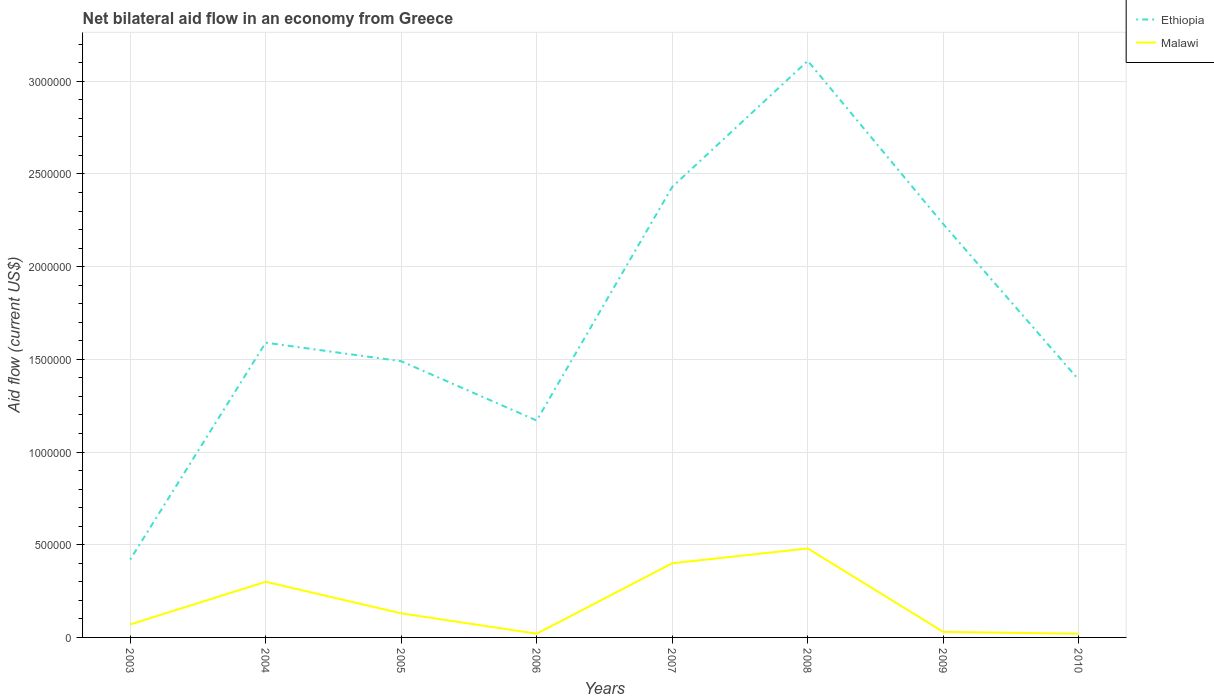Does the line corresponding to Malawi intersect with the line corresponding to Ethiopia?
Your answer should be very brief. No. Is the number of lines equal to the number of legend labels?
Your answer should be compact. Yes. Across all years, what is the maximum net bilateral aid flow in Ethiopia?
Offer a terse response. 4.20e+05. What is the total net bilateral aid flow in Ethiopia in the graph?
Offer a terse response. -2.01e+06. What is the difference between the highest and the second highest net bilateral aid flow in Ethiopia?
Your answer should be very brief. 2.69e+06. How many years are there in the graph?
Your response must be concise. 8. What is the difference between two consecutive major ticks on the Y-axis?
Your response must be concise. 5.00e+05. Are the values on the major ticks of Y-axis written in scientific E-notation?
Keep it short and to the point. No. Does the graph contain any zero values?
Offer a terse response. No. How many legend labels are there?
Ensure brevity in your answer.  2. How are the legend labels stacked?
Make the answer very short. Vertical. What is the title of the graph?
Offer a terse response. Net bilateral aid flow in an economy from Greece. Does "Channel Islands" appear as one of the legend labels in the graph?
Give a very brief answer. No. What is the Aid flow (current US$) of Ethiopia in 2004?
Your response must be concise. 1.59e+06. What is the Aid flow (current US$) of Malawi in 2004?
Offer a terse response. 3.00e+05. What is the Aid flow (current US$) of Ethiopia in 2005?
Provide a succinct answer. 1.49e+06. What is the Aid flow (current US$) of Malawi in 2005?
Make the answer very short. 1.30e+05. What is the Aid flow (current US$) of Ethiopia in 2006?
Your answer should be compact. 1.17e+06. What is the Aid flow (current US$) in Malawi in 2006?
Offer a terse response. 2.00e+04. What is the Aid flow (current US$) of Ethiopia in 2007?
Keep it short and to the point. 2.43e+06. What is the Aid flow (current US$) in Ethiopia in 2008?
Offer a very short reply. 3.11e+06. What is the Aid flow (current US$) in Malawi in 2008?
Offer a terse response. 4.80e+05. What is the Aid flow (current US$) of Ethiopia in 2009?
Make the answer very short. 2.23e+06. What is the Aid flow (current US$) of Malawi in 2009?
Make the answer very short. 3.00e+04. What is the Aid flow (current US$) in Ethiopia in 2010?
Your answer should be very brief. 1.39e+06. What is the Aid flow (current US$) in Malawi in 2010?
Provide a short and direct response. 2.00e+04. Across all years, what is the maximum Aid flow (current US$) of Ethiopia?
Provide a succinct answer. 3.11e+06. Across all years, what is the maximum Aid flow (current US$) in Malawi?
Make the answer very short. 4.80e+05. Across all years, what is the minimum Aid flow (current US$) of Malawi?
Your response must be concise. 2.00e+04. What is the total Aid flow (current US$) of Ethiopia in the graph?
Keep it short and to the point. 1.38e+07. What is the total Aid flow (current US$) in Malawi in the graph?
Offer a terse response. 1.45e+06. What is the difference between the Aid flow (current US$) in Ethiopia in 2003 and that in 2004?
Offer a very short reply. -1.17e+06. What is the difference between the Aid flow (current US$) in Malawi in 2003 and that in 2004?
Your answer should be compact. -2.30e+05. What is the difference between the Aid flow (current US$) of Ethiopia in 2003 and that in 2005?
Provide a short and direct response. -1.07e+06. What is the difference between the Aid flow (current US$) in Malawi in 2003 and that in 2005?
Offer a very short reply. -6.00e+04. What is the difference between the Aid flow (current US$) in Ethiopia in 2003 and that in 2006?
Make the answer very short. -7.50e+05. What is the difference between the Aid flow (current US$) of Malawi in 2003 and that in 2006?
Provide a succinct answer. 5.00e+04. What is the difference between the Aid flow (current US$) of Ethiopia in 2003 and that in 2007?
Make the answer very short. -2.01e+06. What is the difference between the Aid flow (current US$) of Malawi in 2003 and that in 2007?
Make the answer very short. -3.30e+05. What is the difference between the Aid flow (current US$) in Ethiopia in 2003 and that in 2008?
Your answer should be very brief. -2.69e+06. What is the difference between the Aid flow (current US$) in Malawi in 2003 and that in 2008?
Make the answer very short. -4.10e+05. What is the difference between the Aid flow (current US$) of Ethiopia in 2003 and that in 2009?
Your response must be concise. -1.81e+06. What is the difference between the Aid flow (current US$) in Malawi in 2003 and that in 2009?
Your answer should be compact. 4.00e+04. What is the difference between the Aid flow (current US$) in Ethiopia in 2003 and that in 2010?
Keep it short and to the point. -9.70e+05. What is the difference between the Aid flow (current US$) of Malawi in 2004 and that in 2005?
Your response must be concise. 1.70e+05. What is the difference between the Aid flow (current US$) of Ethiopia in 2004 and that in 2006?
Your response must be concise. 4.20e+05. What is the difference between the Aid flow (current US$) in Ethiopia in 2004 and that in 2007?
Provide a short and direct response. -8.40e+05. What is the difference between the Aid flow (current US$) in Malawi in 2004 and that in 2007?
Your answer should be compact. -1.00e+05. What is the difference between the Aid flow (current US$) in Ethiopia in 2004 and that in 2008?
Make the answer very short. -1.52e+06. What is the difference between the Aid flow (current US$) of Ethiopia in 2004 and that in 2009?
Offer a very short reply. -6.40e+05. What is the difference between the Aid flow (current US$) in Malawi in 2004 and that in 2009?
Give a very brief answer. 2.70e+05. What is the difference between the Aid flow (current US$) of Ethiopia in 2004 and that in 2010?
Your answer should be compact. 2.00e+05. What is the difference between the Aid flow (current US$) in Malawi in 2004 and that in 2010?
Ensure brevity in your answer.  2.80e+05. What is the difference between the Aid flow (current US$) of Ethiopia in 2005 and that in 2007?
Make the answer very short. -9.40e+05. What is the difference between the Aid flow (current US$) of Ethiopia in 2005 and that in 2008?
Give a very brief answer. -1.62e+06. What is the difference between the Aid flow (current US$) of Malawi in 2005 and that in 2008?
Make the answer very short. -3.50e+05. What is the difference between the Aid flow (current US$) of Ethiopia in 2005 and that in 2009?
Ensure brevity in your answer.  -7.40e+05. What is the difference between the Aid flow (current US$) in Malawi in 2005 and that in 2009?
Keep it short and to the point. 1.00e+05. What is the difference between the Aid flow (current US$) in Ethiopia in 2006 and that in 2007?
Provide a short and direct response. -1.26e+06. What is the difference between the Aid flow (current US$) of Malawi in 2006 and that in 2007?
Offer a very short reply. -3.80e+05. What is the difference between the Aid flow (current US$) in Ethiopia in 2006 and that in 2008?
Your response must be concise. -1.94e+06. What is the difference between the Aid flow (current US$) in Malawi in 2006 and that in 2008?
Give a very brief answer. -4.60e+05. What is the difference between the Aid flow (current US$) in Ethiopia in 2006 and that in 2009?
Keep it short and to the point. -1.06e+06. What is the difference between the Aid flow (current US$) in Malawi in 2006 and that in 2009?
Provide a short and direct response. -10000. What is the difference between the Aid flow (current US$) in Malawi in 2006 and that in 2010?
Your answer should be compact. 0. What is the difference between the Aid flow (current US$) in Ethiopia in 2007 and that in 2008?
Your answer should be very brief. -6.80e+05. What is the difference between the Aid flow (current US$) in Malawi in 2007 and that in 2008?
Your answer should be compact. -8.00e+04. What is the difference between the Aid flow (current US$) in Ethiopia in 2007 and that in 2009?
Make the answer very short. 2.00e+05. What is the difference between the Aid flow (current US$) of Ethiopia in 2007 and that in 2010?
Your answer should be compact. 1.04e+06. What is the difference between the Aid flow (current US$) of Malawi in 2007 and that in 2010?
Provide a short and direct response. 3.80e+05. What is the difference between the Aid flow (current US$) in Ethiopia in 2008 and that in 2009?
Your answer should be very brief. 8.80e+05. What is the difference between the Aid flow (current US$) in Ethiopia in 2008 and that in 2010?
Offer a terse response. 1.72e+06. What is the difference between the Aid flow (current US$) of Malawi in 2008 and that in 2010?
Offer a terse response. 4.60e+05. What is the difference between the Aid flow (current US$) in Ethiopia in 2009 and that in 2010?
Give a very brief answer. 8.40e+05. What is the difference between the Aid flow (current US$) in Malawi in 2009 and that in 2010?
Keep it short and to the point. 10000. What is the difference between the Aid flow (current US$) of Ethiopia in 2003 and the Aid flow (current US$) of Malawi in 2004?
Offer a terse response. 1.20e+05. What is the difference between the Aid flow (current US$) in Ethiopia in 2003 and the Aid flow (current US$) in Malawi in 2006?
Keep it short and to the point. 4.00e+05. What is the difference between the Aid flow (current US$) of Ethiopia in 2003 and the Aid flow (current US$) of Malawi in 2007?
Make the answer very short. 2.00e+04. What is the difference between the Aid flow (current US$) in Ethiopia in 2004 and the Aid flow (current US$) in Malawi in 2005?
Offer a very short reply. 1.46e+06. What is the difference between the Aid flow (current US$) in Ethiopia in 2004 and the Aid flow (current US$) in Malawi in 2006?
Provide a succinct answer. 1.57e+06. What is the difference between the Aid flow (current US$) in Ethiopia in 2004 and the Aid flow (current US$) in Malawi in 2007?
Offer a very short reply. 1.19e+06. What is the difference between the Aid flow (current US$) in Ethiopia in 2004 and the Aid flow (current US$) in Malawi in 2008?
Ensure brevity in your answer.  1.11e+06. What is the difference between the Aid flow (current US$) in Ethiopia in 2004 and the Aid flow (current US$) in Malawi in 2009?
Your response must be concise. 1.56e+06. What is the difference between the Aid flow (current US$) in Ethiopia in 2004 and the Aid flow (current US$) in Malawi in 2010?
Keep it short and to the point. 1.57e+06. What is the difference between the Aid flow (current US$) in Ethiopia in 2005 and the Aid flow (current US$) in Malawi in 2006?
Make the answer very short. 1.47e+06. What is the difference between the Aid flow (current US$) in Ethiopia in 2005 and the Aid flow (current US$) in Malawi in 2007?
Provide a short and direct response. 1.09e+06. What is the difference between the Aid flow (current US$) in Ethiopia in 2005 and the Aid flow (current US$) in Malawi in 2008?
Keep it short and to the point. 1.01e+06. What is the difference between the Aid flow (current US$) of Ethiopia in 2005 and the Aid flow (current US$) of Malawi in 2009?
Offer a very short reply. 1.46e+06. What is the difference between the Aid flow (current US$) of Ethiopia in 2005 and the Aid flow (current US$) of Malawi in 2010?
Give a very brief answer. 1.47e+06. What is the difference between the Aid flow (current US$) in Ethiopia in 2006 and the Aid flow (current US$) in Malawi in 2007?
Offer a very short reply. 7.70e+05. What is the difference between the Aid flow (current US$) in Ethiopia in 2006 and the Aid flow (current US$) in Malawi in 2008?
Provide a succinct answer. 6.90e+05. What is the difference between the Aid flow (current US$) of Ethiopia in 2006 and the Aid flow (current US$) of Malawi in 2009?
Offer a terse response. 1.14e+06. What is the difference between the Aid flow (current US$) in Ethiopia in 2006 and the Aid flow (current US$) in Malawi in 2010?
Your answer should be very brief. 1.15e+06. What is the difference between the Aid flow (current US$) in Ethiopia in 2007 and the Aid flow (current US$) in Malawi in 2008?
Provide a short and direct response. 1.95e+06. What is the difference between the Aid flow (current US$) of Ethiopia in 2007 and the Aid flow (current US$) of Malawi in 2009?
Keep it short and to the point. 2.40e+06. What is the difference between the Aid flow (current US$) of Ethiopia in 2007 and the Aid flow (current US$) of Malawi in 2010?
Your answer should be compact. 2.41e+06. What is the difference between the Aid flow (current US$) of Ethiopia in 2008 and the Aid flow (current US$) of Malawi in 2009?
Offer a terse response. 3.08e+06. What is the difference between the Aid flow (current US$) in Ethiopia in 2008 and the Aid flow (current US$) in Malawi in 2010?
Keep it short and to the point. 3.09e+06. What is the difference between the Aid flow (current US$) of Ethiopia in 2009 and the Aid flow (current US$) of Malawi in 2010?
Keep it short and to the point. 2.21e+06. What is the average Aid flow (current US$) of Ethiopia per year?
Ensure brevity in your answer.  1.73e+06. What is the average Aid flow (current US$) in Malawi per year?
Offer a very short reply. 1.81e+05. In the year 2004, what is the difference between the Aid flow (current US$) of Ethiopia and Aid flow (current US$) of Malawi?
Keep it short and to the point. 1.29e+06. In the year 2005, what is the difference between the Aid flow (current US$) of Ethiopia and Aid flow (current US$) of Malawi?
Ensure brevity in your answer.  1.36e+06. In the year 2006, what is the difference between the Aid flow (current US$) of Ethiopia and Aid flow (current US$) of Malawi?
Give a very brief answer. 1.15e+06. In the year 2007, what is the difference between the Aid flow (current US$) in Ethiopia and Aid flow (current US$) in Malawi?
Provide a short and direct response. 2.03e+06. In the year 2008, what is the difference between the Aid flow (current US$) of Ethiopia and Aid flow (current US$) of Malawi?
Offer a very short reply. 2.63e+06. In the year 2009, what is the difference between the Aid flow (current US$) of Ethiopia and Aid flow (current US$) of Malawi?
Your answer should be very brief. 2.20e+06. In the year 2010, what is the difference between the Aid flow (current US$) of Ethiopia and Aid flow (current US$) of Malawi?
Ensure brevity in your answer.  1.37e+06. What is the ratio of the Aid flow (current US$) in Ethiopia in 2003 to that in 2004?
Provide a short and direct response. 0.26. What is the ratio of the Aid flow (current US$) in Malawi in 2003 to that in 2004?
Ensure brevity in your answer.  0.23. What is the ratio of the Aid flow (current US$) of Ethiopia in 2003 to that in 2005?
Your answer should be compact. 0.28. What is the ratio of the Aid flow (current US$) in Malawi in 2003 to that in 2005?
Keep it short and to the point. 0.54. What is the ratio of the Aid flow (current US$) in Ethiopia in 2003 to that in 2006?
Ensure brevity in your answer.  0.36. What is the ratio of the Aid flow (current US$) of Malawi in 2003 to that in 2006?
Your answer should be compact. 3.5. What is the ratio of the Aid flow (current US$) of Ethiopia in 2003 to that in 2007?
Offer a very short reply. 0.17. What is the ratio of the Aid flow (current US$) in Malawi in 2003 to that in 2007?
Offer a terse response. 0.17. What is the ratio of the Aid flow (current US$) of Ethiopia in 2003 to that in 2008?
Give a very brief answer. 0.14. What is the ratio of the Aid flow (current US$) in Malawi in 2003 to that in 2008?
Ensure brevity in your answer.  0.15. What is the ratio of the Aid flow (current US$) in Ethiopia in 2003 to that in 2009?
Keep it short and to the point. 0.19. What is the ratio of the Aid flow (current US$) of Malawi in 2003 to that in 2009?
Offer a very short reply. 2.33. What is the ratio of the Aid flow (current US$) in Ethiopia in 2003 to that in 2010?
Give a very brief answer. 0.3. What is the ratio of the Aid flow (current US$) of Malawi in 2003 to that in 2010?
Provide a short and direct response. 3.5. What is the ratio of the Aid flow (current US$) of Ethiopia in 2004 to that in 2005?
Offer a terse response. 1.07. What is the ratio of the Aid flow (current US$) in Malawi in 2004 to that in 2005?
Make the answer very short. 2.31. What is the ratio of the Aid flow (current US$) in Ethiopia in 2004 to that in 2006?
Offer a terse response. 1.36. What is the ratio of the Aid flow (current US$) in Malawi in 2004 to that in 2006?
Keep it short and to the point. 15. What is the ratio of the Aid flow (current US$) in Ethiopia in 2004 to that in 2007?
Make the answer very short. 0.65. What is the ratio of the Aid flow (current US$) of Ethiopia in 2004 to that in 2008?
Keep it short and to the point. 0.51. What is the ratio of the Aid flow (current US$) in Malawi in 2004 to that in 2008?
Provide a short and direct response. 0.62. What is the ratio of the Aid flow (current US$) in Ethiopia in 2004 to that in 2009?
Ensure brevity in your answer.  0.71. What is the ratio of the Aid flow (current US$) of Malawi in 2004 to that in 2009?
Give a very brief answer. 10. What is the ratio of the Aid flow (current US$) of Ethiopia in 2004 to that in 2010?
Provide a succinct answer. 1.14. What is the ratio of the Aid flow (current US$) of Ethiopia in 2005 to that in 2006?
Offer a very short reply. 1.27. What is the ratio of the Aid flow (current US$) of Malawi in 2005 to that in 2006?
Your answer should be compact. 6.5. What is the ratio of the Aid flow (current US$) of Ethiopia in 2005 to that in 2007?
Your answer should be compact. 0.61. What is the ratio of the Aid flow (current US$) in Malawi in 2005 to that in 2007?
Offer a terse response. 0.33. What is the ratio of the Aid flow (current US$) of Ethiopia in 2005 to that in 2008?
Provide a short and direct response. 0.48. What is the ratio of the Aid flow (current US$) of Malawi in 2005 to that in 2008?
Provide a short and direct response. 0.27. What is the ratio of the Aid flow (current US$) in Ethiopia in 2005 to that in 2009?
Provide a short and direct response. 0.67. What is the ratio of the Aid flow (current US$) in Malawi in 2005 to that in 2009?
Provide a short and direct response. 4.33. What is the ratio of the Aid flow (current US$) of Ethiopia in 2005 to that in 2010?
Your answer should be very brief. 1.07. What is the ratio of the Aid flow (current US$) in Malawi in 2005 to that in 2010?
Your answer should be compact. 6.5. What is the ratio of the Aid flow (current US$) in Ethiopia in 2006 to that in 2007?
Give a very brief answer. 0.48. What is the ratio of the Aid flow (current US$) in Malawi in 2006 to that in 2007?
Make the answer very short. 0.05. What is the ratio of the Aid flow (current US$) in Ethiopia in 2006 to that in 2008?
Your answer should be very brief. 0.38. What is the ratio of the Aid flow (current US$) of Malawi in 2006 to that in 2008?
Provide a succinct answer. 0.04. What is the ratio of the Aid flow (current US$) of Ethiopia in 2006 to that in 2009?
Provide a succinct answer. 0.52. What is the ratio of the Aid flow (current US$) of Ethiopia in 2006 to that in 2010?
Offer a terse response. 0.84. What is the ratio of the Aid flow (current US$) in Ethiopia in 2007 to that in 2008?
Your answer should be compact. 0.78. What is the ratio of the Aid flow (current US$) in Malawi in 2007 to that in 2008?
Provide a short and direct response. 0.83. What is the ratio of the Aid flow (current US$) in Ethiopia in 2007 to that in 2009?
Give a very brief answer. 1.09. What is the ratio of the Aid flow (current US$) of Malawi in 2007 to that in 2009?
Your response must be concise. 13.33. What is the ratio of the Aid flow (current US$) in Ethiopia in 2007 to that in 2010?
Offer a terse response. 1.75. What is the ratio of the Aid flow (current US$) in Malawi in 2007 to that in 2010?
Offer a very short reply. 20. What is the ratio of the Aid flow (current US$) of Ethiopia in 2008 to that in 2009?
Offer a terse response. 1.39. What is the ratio of the Aid flow (current US$) of Malawi in 2008 to that in 2009?
Keep it short and to the point. 16. What is the ratio of the Aid flow (current US$) in Ethiopia in 2008 to that in 2010?
Ensure brevity in your answer.  2.24. What is the ratio of the Aid flow (current US$) in Ethiopia in 2009 to that in 2010?
Ensure brevity in your answer.  1.6. What is the ratio of the Aid flow (current US$) of Malawi in 2009 to that in 2010?
Make the answer very short. 1.5. What is the difference between the highest and the second highest Aid flow (current US$) of Ethiopia?
Offer a very short reply. 6.80e+05. What is the difference between the highest and the second highest Aid flow (current US$) in Malawi?
Keep it short and to the point. 8.00e+04. What is the difference between the highest and the lowest Aid flow (current US$) of Ethiopia?
Make the answer very short. 2.69e+06. 